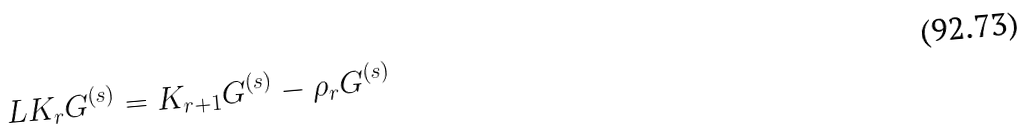<formula> <loc_0><loc_0><loc_500><loc_500>L K _ { r } G ^ { ( s ) } = K _ { r + 1 } G ^ { ( s ) } - \rho _ { r } G ^ { ( s ) }</formula> 